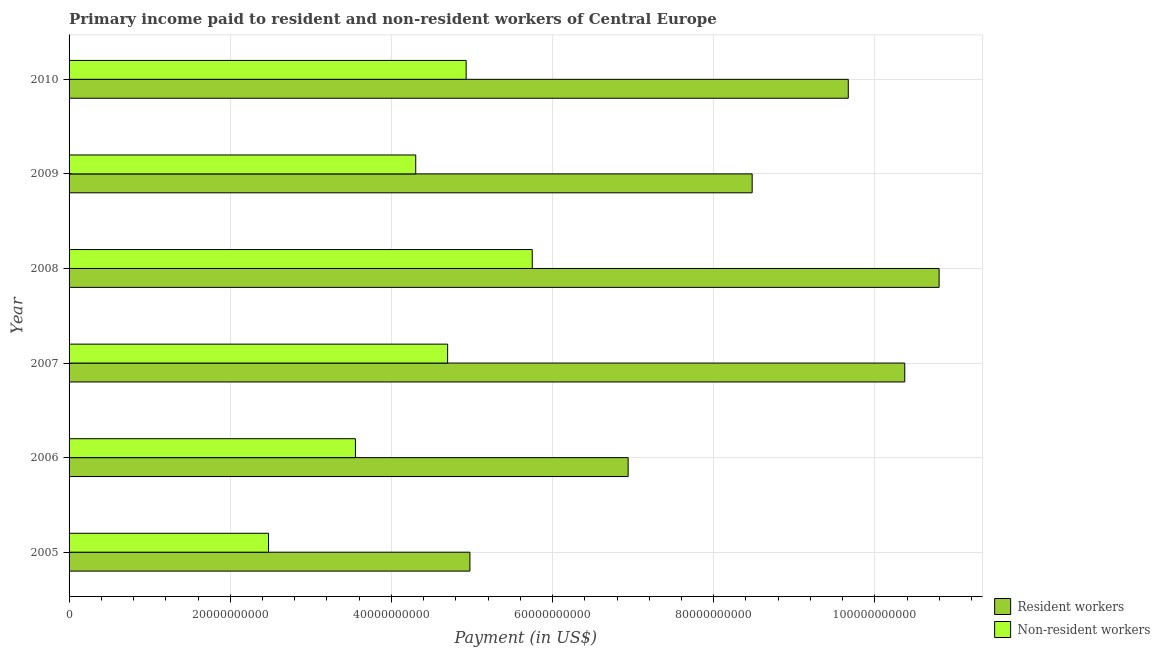How many groups of bars are there?
Offer a very short reply. 6. Are the number of bars per tick equal to the number of legend labels?
Offer a very short reply. Yes. How many bars are there on the 3rd tick from the top?
Your response must be concise. 2. How many bars are there on the 2nd tick from the bottom?
Offer a terse response. 2. What is the label of the 5th group of bars from the top?
Keep it short and to the point. 2006. What is the payment made to resident workers in 2006?
Provide a short and direct response. 6.94e+1. Across all years, what is the maximum payment made to non-resident workers?
Provide a short and direct response. 5.75e+1. Across all years, what is the minimum payment made to resident workers?
Ensure brevity in your answer.  4.97e+1. In which year was the payment made to non-resident workers minimum?
Ensure brevity in your answer.  2005. What is the total payment made to resident workers in the graph?
Provide a succinct answer. 5.12e+11. What is the difference between the payment made to resident workers in 2006 and that in 2008?
Your response must be concise. -3.86e+1. What is the difference between the payment made to non-resident workers in 2008 and the payment made to resident workers in 2010?
Offer a very short reply. -3.92e+1. What is the average payment made to resident workers per year?
Make the answer very short. 8.54e+1. In the year 2009, what is the difference between the payment made to resident workers and payment made to non-resident workers?
Make the answer very short. 4.18e+1. In how many years, is the payment made to non-resident workers greater than 8000000000 US$?
Ensure brevity in your answer.  6. What is the ratio of the payment made to non-resident workers in 2009 to that in 2010?
Your answer should be compact. 0.87. What is the difference between the highest and the second highest payment made to non-resident workers?
Keep it short and to the point. 8.20e+09. What is the difference between the highest and the lowest payment made to non-resident workers?
Offer a very short reply. 3.27e+1. Is the sum of the payment made to non-resident workers in 2005 and 2009 greater than the maximum payment made to resident workers across all years?
Give a very brief answer. No. What does the 2nd bar from the top in 2008 represents?
Give a very brief answer. Resident workers. What does the 1st bar from the bottom in 2007 represents?
Ensure brevity in your answer.  Resident workers. How many bars are there?
Keep it short and to the point. 12. Are all the bars in the graph horizontal?
Offer a terse response. Yes. How many years are there in the graph?
Provide a short and direct response. 6. What is the difference between two consecutive major ticks on the X-axis?
Offer a very short reply. 2.00e+1. Are the values on the major ticks of X-axis written in scientific E-notation?
Your response must be concise. No. Where does the legend appear in the graph?
Your response must be concise. Bottom right. What is the title of the graph?
Provide a short and direct response. Primary income paid to resident and non-resident workers of Central Europe. What is the label or title of the X-axis?
Provide a succinct answer. Payment (in US$). What is the label or title of the Y-axis?
Your response must be concise. Year. What is the Payment (in US$) of Resident workers in 2005?
Provide a short and direct response. 4.97e+1. What is the Payment (in US$) of Non-resident workers in 2005?
Give a very brief answer. 2.48e+1. What is the Payment (in US$) of Resident workers in 2006?
Ensure brevity in your answer.  6.94e+1. What is the Payment (in US$) in Non-resident workers in 2006?
Offer a very short reply. 3.55e+1. What is the Payment (in US$) of Resident workers in 2007?
Make the answer very short. 1.04e+11. What is the Payment (in US$) in Non-resident workers in 2007?
Ensure brevity in your answer.  4.70e+1. What is the Payment (in US$) of Resident workers in 2008?
Offer a terse response. 1.08e+11. What is the Payment (in US$) in Non-resident workers in 2008?
Offer a very short reply. 5.75e+1. What is the Payment (in US$) of Resident workers in 2009?
Your answer should be very brief. 8.48e+1. What is the Payment (in US$) in Non-resident workers in 2009?
Your answer should be very brief. 4.30e+1. What is the Payment (in US$) of Resident workers in 2010?
Offer a terse response. 9.67e+1. What is the Payment (in US$) in Non-resident workers in 2010?
Give a very brief answer. 4.93e+1. Across all years, what is the maximum Payment (in US$) of Resident workers?
Your response must be concise. 1.08e+11. Across all years, what is the maximum Payment (in US$) in Non-resident workers?
Ensure brevity in your answer.  5.75e+1. Across all years, what is the minimum Payment (in US$) in Resident workers?
Offer a terse response. 4.97e+1. Across all years, what is the minimum Payment (in US$) in Non-resident workers?
Ensure brevity in your answer.  2.48e+1. What is the total Payment (in US$) in Resident workers in the graph?
Give a very brief answer. 5.12e+11. What is the total Payment (in US$) in Non-resident workers in the graph?
Offer a terse response. 2.57e+11. What is the difference between the Payment (in US$) in Resident workers in 2005 and that in 2006?
Give a very brief answer. -1.96e+1. What is the difference between the Payment (in US$) of Non-resident workers in 2005 and that in 2006?
Offer a terse response. -1.08e+1. What is the difference between the Payment (in US$) of Resident workers in 2005 and that in 2007?
Offer a very short reply. -5.40e+1. What is the difference between the Payment (in US$) of Non-resident workers in 2005 and that in 2007?
Your response must be concise. -2.22e+1. What is the difference between the Payment (in US$) of Resident workers in 2005 and that in 2008?
Ensure brevity in your answer.  -5.82e+1. What is the difference between the Payment (in US$) in Non-resident workers in 2005 and that in 2008?
Your answer should be very brief. -3.27e+1. What is the difference between the Payment (in US$) of Resident workers in 2005 and that in 2009?
Provide a succinct answer. -3.50e+1. What is the difference between the Payment (in US$) in Non-resident workers in 2005 and that in 2009?
Offer a very short reply. -1.83e+1. What is the difference between the Payment (in US$) of Resident workers in 2005 and that in 2010?
Keep it short and to the point. -4.70e+1. What is the difference between the Payment (in US$) of Non-resident workers in 2005 and that in 2010?
Ensure brevity in your answer.  -2.45e+1. What is the difference between the Payment (in US$) in Resident workers in 2006 and that in 2007?
Provide a short and direct response. -3.43e+1. What is the difference between the Payment (in US$) in Non-resident workers in 2006 and that in 2007?
Make the answer very short. -1.14e+1. What is the difference between the Payment (in US$) of Resident workers in 2006 and that in 2008?
Your response must be concise. -3.86e+1. What is the difference between the Payment (in US$) of Non-resident workers in 2006 and that in 2008?
Offer a terse response. -2.19e+1. What is the difference between the Payment (in US$) of Resident workers in 2006 and that in 2009?
Your response must be concise. -1.54e+1. What is the difference between the Payment (in US$) of Non-resident workers in 2006 and that in 2009?
Your answer should be very brief. -7.48e+09. What is the difference between the Payment (in US$) in Resident workers in 2006 and that in 2010?
Provide a succinct answer. -2.73e+1. What is the difference between the Payment (in US$) in Non-resident workers in 2006 and that in 2010?
Make the answer very short. -1.37e+1. What is the difference between the Payment (in US$) of Resident workers in 2007 and that in 2008?
Offer a very short reply. -4.27e+09. What is the difference between the Payment (in US$) of Non-resident workers in 2007 and that in 2008?
Offer a terse response. -1.05e+1. What is the difference between the Payment (in US$) of Resident workers in 2007 and that in 2009?
Offer a very short reply. 1.89e+1. What is the difference between the Payment (in US$) of Non-resident workers in 2007 and that in 2009?
Your answer should be compact. 3.96e+09. What is the difference between the Payment (in US$) of Resident workers in 2007 and that in 2010?
Provide a succinct answer. 7.01e+09. What is the difference between the Payment (in US$) in Non-resident workers in 2007 and that in 2010?
Offer a very short reply. -2.30e+09. What is the difference between the Payment (in US$) of Resident workers in 2008 and that in 2009?
Your answer should be compact. 2.32e+1. What is the difference between the Payment (in US$) of Non-resident workers in 2008 and that in 2009?
Provide a succinct answer. 1.45e+1. What is the difference between the Payment (in US$) in Resident workers in 2008 and that in 2010?
Provide a short and direct response. 1.13e+1. What is the difference between the Payment (in US$) in Non-resident workers in 2008 and that in 2010?
Keep it short and to the point. 8.20e+09. What is the difference between the Payment (in US$) of Resident workers in 2009 and that in 2010?
Ensure brevity in your answer.  -1.19e+1. What is the difference between the Payment (in US$) of Non-resident workers in 2009 and that in 2010?
Make the answer very short. -6.26e+09. What is the difference between the Payment (in US$) of Resident workers in 2005 and the Payment (in US$) of Non-resident workers in 2006?
Keep it short and to the point. 1.42e+1. What is the difference between the Payment (in US$) in Resident workers in 2005 and the Payment (in US$) in Non-resident workers in 2007?
Give a very brief answer. 2.77e+09. What is the difference between the Payment (in US$) of Resident workers in 2005 and the Payment (in US$) of Non-resident workers in 2008?
Provide a succinct answer. -7.73e+09. What is the difference between the Payment (in US$) of Resident workers in 2005 and the Payment (in US$) of Non-resident workers in 2009?
Provide a succinct answer. 6.73e+09. What is the difference between the Payment (in US$) of Resident workers in 2005 and the Payment (in US$) of Non-resident workers in 2010?
Ensure brevity in your answer.  4.68e+08. What is the difference between the Payment (in US$) of Resident workers in 2006 and the Payment (in US$) of Non-resident workers in 2007?
Offer a very short reply. 2.24e+1. What is the difference between the Payment (in US$) in Resident workers in 2006 and the Payment (in US$) in Non-resident workers in 2008?
Keep it short and to the point. 1.19e+1. What is the difference between the Payment (in US$) in Resident workers in 2006 and the Payment (in US$) in Non-resident workers in 2009?
Provide a short and direct response. 2.64e+1. What is the difference between the Payment (in US$) of Resident workers in 2006 and the Payment (in US$) of Non-resident workers in 2010?
Keep it short and to the point. 2.01e+1. What is the difference between the Payment (in US$) in Resident workers in 2007 and the Payment (in US$) in Non-resident workers in 2008?
Make the answer very short. 4.62e+1. What is the difference between the Payment (in US$) of Resident workers in 2007 and the Payment (in US$) of Non-resident workers in 2009?
Your answer should be very brief. 6.07e+1. What is the difference between the Payment (in US$) in Resident workers in 2007 and the Payment (in US$) in Non-resident workers in 2010?
Provide a succinct answer. 5.44e+1. What is the difference between the Payment (in US$) in Resident workers in 2008 and the Payment (in US$) in Non-resident workers in 2009?
Your answer should be compact. 6.50e+1. What is the difference between the Payment (in US$) of Resident workers in 2008 and the Payment (in US$) of Non-resident workers in 2010?
Your response must be concise. 5.87e+1. What is the difference between the Payment (in US$) in Resident workers in 2009 and the Payment (in US$) in Non-resident workers in 2010?
Offer a terse response. 3.55e+1. What is the average Payment (in US$) in Resident workers per year?
Make the answer very short. 8.54e+1. What is the average Payment (in US$) of Non-resident workers per year?
Your answer should be compact. 4.28e+1. In the year 2005, what is the difference between the Payment (in US$) in Resident workers and Payment (in US$) in Non-resident workers?
Provide a succinct answer. 2.50e+1. In the year 2006, what is the difference between the Payment (in US$) of Resident workers and Payment (in US$) of Non-resident workers?
Keep it short and to the point. 3.38e+1. In the year 2007, what is the difference between the Payment (in US$) in Resident workers and Payment (in US$) in Non-resident workers?
Keep it short and to the point. 5.67e+1. In the year 2008, what is the difference between the Payment (in US$) of Resident workers and Payment (in US$) of Non-resident workers?
Keep it short and to the point. 5.05e+1. In the year 2009, what is the difference between the Payment (in US$) of Resident workers and Payment (in US$) of Non-resident workers?
Provide a succinct answer. 4.18e+1. In the year 2010, what is the difference between the Payment (in US$) in Resident workers and Payment (in US$) in Non-resident workers?
Offer a terse response. 4.74e+1. What is the ratio of the Payment (in US$) of Resident workers in 2005 to that in 2006?
Provide a short and direct response. 0.72. What is the ratio of the Payment (in US$) of Non-resident workers in 2005 to that in 2006?
Provide a succinct answer. 0.7. What is the ratio of the Payment (in US$) of Resident workers in 2005 to that in 2007?
Provide a short and direct response. 0.48. What is the ratio of the Payment (in US$) of Non-resident workers in 2005 to that in 2007?
Keep it short and to the point. 0.53. What is the ratio of the Payment (in US$) of Resident workers in 2005 to that in 2008?
Offer a terse response. 0.46. What is the ratio of the Payment (in US$) in Non-resident workers in 2005 to that in 2008?
Give a very brief answer. 0.43. What is the ratio of the Payment (in US$) of Resident workers in 2005 to that in 2009?
Offer a terse response. 0.59. What is the ratio of the Payment (in US$) of Non-resident workers in 2005 to that in 2009?
Your answer should be compact. 0.58. What is the ratio of the Payment (in US$) in Resident workers in 2005 to that in 2010?
Ensure brevity in your answer.  0.51. What is the ratio of the Payment (in US$) in Non-resident workers in 2005 to that in 2010?
Offer a very short reply. 0.5. What is the ratio of the Payment (in US$) in Resident workers in 2006 to that in 2007?
Make the answer very short. 0.67. What is the ratio of the Payment (in US$) of Non-resident workers in 2006 to that in 2007?
Keep it short and to the point. 0.76. What is the ratio of the Payment (in US$) of Resident workers in 2006 to that in 2008?
Offer a terse response. 0.64. What is the ratio of the Payment (in US$) of Non-resident workers in 2006 to that in 2008?
Provide a short and direct response. 0.62. What is the ratio of the Payment (in US$) in Resident workers in 2006 to that in 2009?
Make the answer very short. 0.82. What is the ratio of the Payment (in US$) of Non-resident workers in 2006 to that in 2009?
Offer a terse response. 0.83. What is the ratio of the Payment (in US$) of Resident workers in 2006 to that in 2010?
Provide a succinct answer. 0.72. What is the ratio of the Payment (in US$) in Non-resident workers in 2006 to that in 2010?
Your answer should be very brief. 0.72. What is the ratio of the Payment (in US$) of Resident workers in 2007 to that in 2008?
Provide a succinct answer. 0.96. What is the ratio of the Payment (in US$) in Non-resident workers in 2007 to that in 2008?
Offer a very short reply. 0.82. What is the ratio of the Payment (in US$) of Resident workers in 2007 to that in 2009?
Provide a short and direct response. 1.22. What is the ratio of the Payment (in US$) in Non-resident workers in 2007 to that in 2009?
Your answer should be very brief. 1.09. What is the ratio of the Payment (in US$) in Resident workers in 2007 to that in 2010?
Offer a very short reply. 1.07. What is the ratio of the Payment (in US$) in Non-resident workers in 2007 to that in 2010?
Provide a succinct answer. 0.95. What is the ratio of the Payment (in US$) in Resident workers in 2008 to that in 2009?
Offer a very short reply. 1.27. What is the ratio of the Payment (in US$) in Non-resident workers in 2008 to that in 2009?
Provide a succinct answer. 1.34. What is the ratio of the Payment (in US$) of Resident workers in 2008 to that in 2010?
Your response must be concise. 1.12. What is the ratio of the Payment (in US$) of Non-resident workers in 2008 to that in 2010?
Offer a very short reply. 1.17. What is the ratio of the Payment (in US$) in Resident workers in 2009 to that in 2010?
Provide a short and direct response. 0.88. What is the ratio of the Payment (in US$) in Non-resident workers in 2009 to that in 2010?
Provide a short and direct response. 0.87. What is the difference between the highest and the second highest Payment (in US$) of Resident workers?
Give a very brief answer. 4.27e+09. What is the difference between the highest and the second highest Payment (in US$) in Non-resident workers?
Provide a short and direct response. 8.20e+09. What is the difference between the highest and the lowest Payment (in US$) in Resident workers?
Offer a terse response. 5.82e+1. What is the difference between the highest and the lowest Payment (in US$) of Non-resident workers?
Your response must be concise. 3.27e+1. 